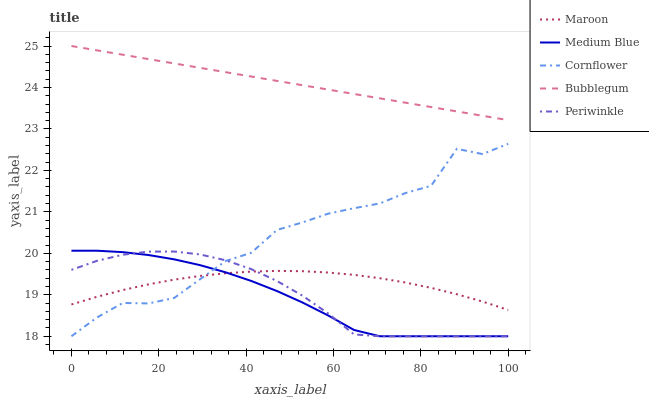Does Medium Blue have the minimum area under the curve?
Answer yes or no. Yes. Does Bubblegum have the maximum area under the curve?
Answer yes or no. Yes. Does Periwinkle have the minimum area under the curve?
Answer yes or no. No. Does Periwinkle have the maximum area under the curve?
Answer yes or no. No. Is Bubblegum the smoothest?
Answer yes or no. Yes. Is Cornflower the roughest?
Answer yes or no. Yes. Is Periwinkle the smoothest?
Answer yes or no. No. Is Periwinkle the roughest?
Answer yes or no. No. Does Cornflower have the lowest value?
Answer yes or no. Yes. Does Bubblegum have the lowest value?
Answer yes or no. No. Does Bubblegum have the highest value?
Answer yes or no. Yes. Does Periwinkle have the highest value?
Answer yes or no. No. Is Cornflower less than Bubblegum?
Answer yes or no. Yes. Is Bubblegum greater than Cornflower?
Answer yes or no. Yes. Does Cornflower intersect Medium Blue?
Answer yes or no. Yes. Is Cornflower less than Medium Blue?
Answer yes or no. No. Is Cornflower greater than Medium Blue?
Answer yes or no. No. Does Cornflower intersect Bubblegum?
Answer yes or no. No. 